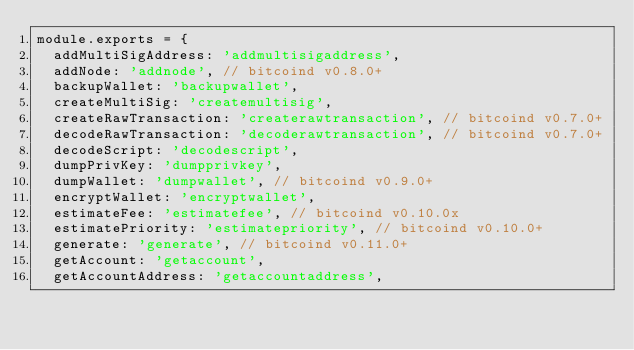Convert code to text. <code><loc_0><loc_0><loc_500><loc_500><_JavaScript_>module.exports = {
  addMultiSigAddress: 'addmultisigaddress',
  addNode: 'addnode', // bitcoind v0.8.0+
  backupWallet: 'backupwallet',
  createMultiSig: 'createmultisig',
  createRawTransaction: 'createrawtransaction', // bitcoind v0.7.0+
  decodeRawTransaction: 'decoderawtransaction', // bitcoind v0.7.0+
  decodeScript: 'decodescript',
  dumpPrivKey: 'dumpprivkey',
  dumpWallet: 'dumpwallet', // bitcoind v0.9.0+
  encryptWallet: 'encryptwallet',
  estimateFee: 'estimatefee', // bitcoind v0.10.0x
  estimatePriority: 'estimatepriority', // bitcoind v0.10.0+
  generate: 'generate', // bitcoind v0.11.0+
  getAccount: 'getaccount',
  getAccountAddress: 'getaccountaddress',</code> 